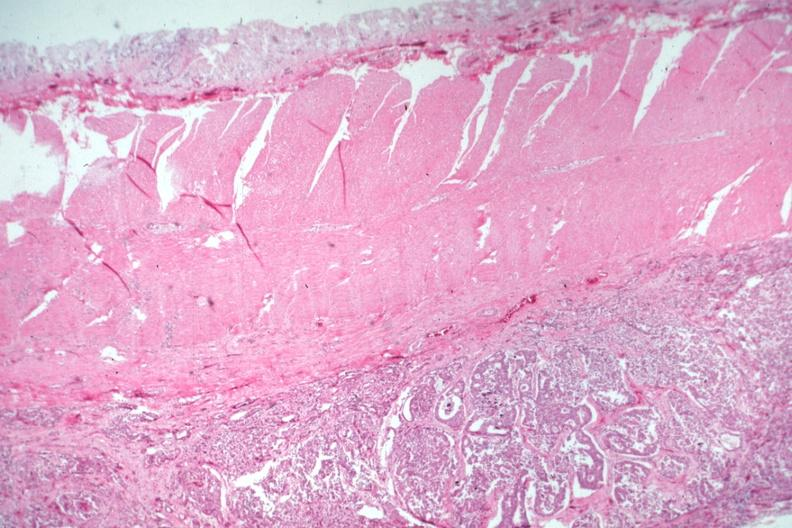where is this from?
Answer the question using a single word or phrase. Gastrointestinal system 